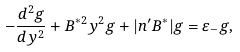Convert formula to latex. <formula><loc_0><loc_0><loc_500><loc_500>- \frac { d ^ { 2 } g } { d y ^ { 2 } } + B ^ { * 2 } y ^ { 2 } g + | n ^ { \prime } B ^ { * } | g = \varepsilon _ { - } g ,</formula> 